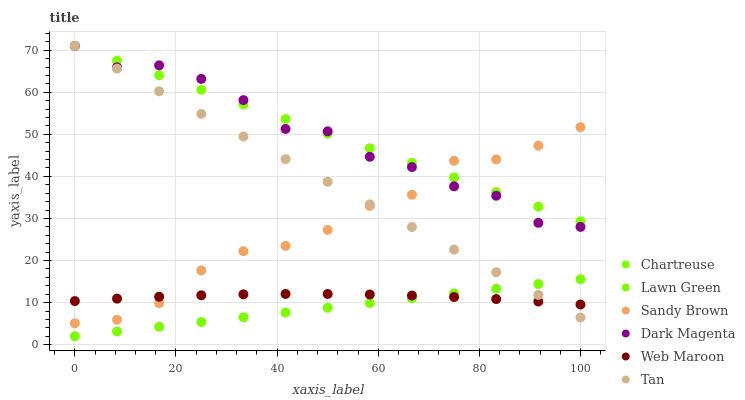Does Lawn Green have the minimum area under the curve?
Answer yes or no. Yes. Does Chartreuse have the maximum area under the curve?
Answer yes or no. Yes. Does Dark Magenta have the minimum area under the curve?
Answer yes or no. No. Does Dark Magenta have the maximum area under the curve?
Answer yes or no. No. Is Lawn Green the smoothest?
Answer yes or no. Yes. Is Dark Magenta the roughest?
Answer yes or no. Yes. Is Web Maroon the smoothest?
Answer yes or no. No. Is Web Maroon the roughest?
Answer yes or no. No. Does Lawn Green have the lowest value?
Answer yes or no. Yes. Does Dark Magenta have the lowest value?
Answer yes or no. No. Does Tan have the highest value?
Answer yes or no. Yes. Does Web Maroon have the highest value?
Answer yes or no. No. Is Lawn Green less than Dark Magenta?
Answer yes or no. Yes. Is Chartreuse greater than Lawn Green?
Answer yes or no. Yes. Does Chartreuse intersect Tan?
Answer yes or no. Yes. Is Chartreuse less than Tan?
Answer yes or no. No. Is Chartreuse greater than Tan?
Answer yes or no. No. Does Lawn Green intersect Dark Magenta?
Answer yes or no. No. 